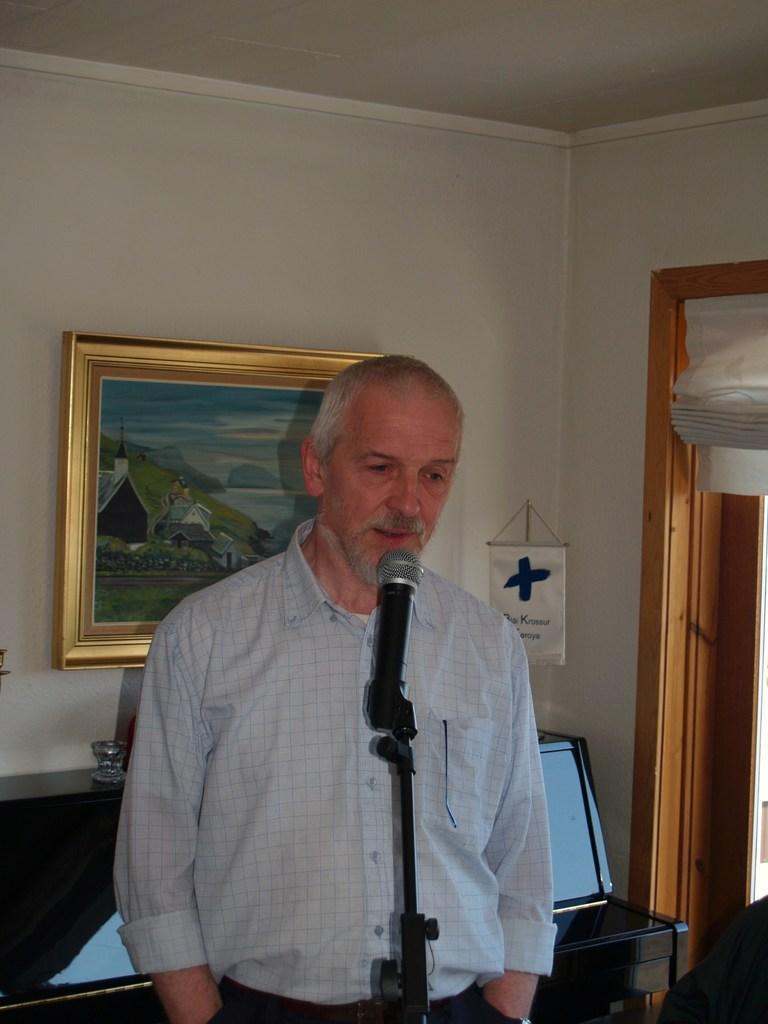Could you give a brief overview of what you see in this image? In this image we can see a person giving a talk. And we can see mike in front side. And behind we can see a wall on which one painting is there. And another object is hanged. And we can see the door. And we can see some objects are placed on the wooden table. 